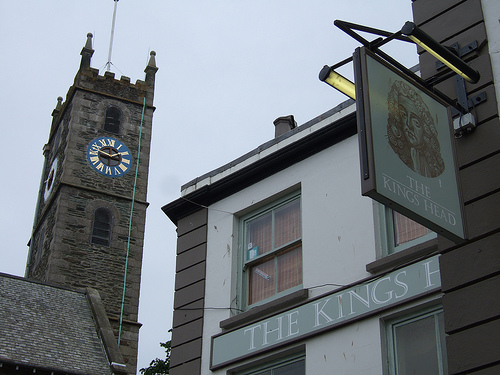Does the window of the building look curved? Yes, the top window in the image exhibits a subtle, unique curvature that contributes to the charming architectural details of the building's facade. 